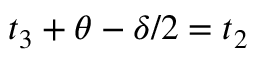Convert formula to latex. <formula><loc_0><loc_0><loc_500><loc_500>t _ { 3 } + \theta - \delta / 2 = t _ { 2 }</formula> 